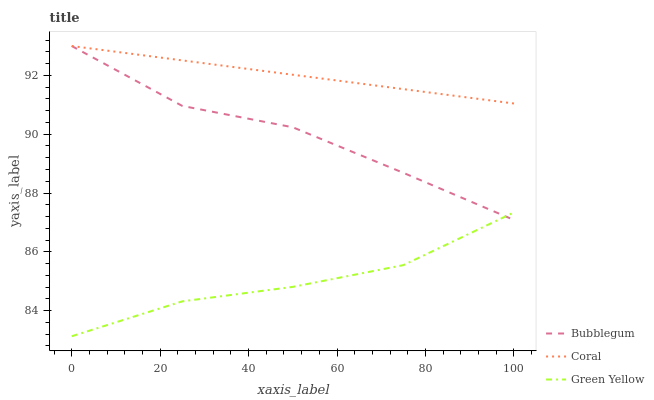Does Green Yellow have the minimum area under the curve?
Answer yes or no. Yes. Does Coral have the maximum area under the curve?
Answer yes or no. Yes. Does Bubblegum have the minimum area under the curve?
Answer yes or no. No. Does Bubblegum have the maximum area under the curve?
Answer yes or no. No. Is Coral the smoothest?
Answer yes or no. Yes. Is Bubblegum the roughest?
Answer yes or no. Yes. Is Green Yellow the smoothest?
Answer yes or no. No. Is Green Yellow the roughest?
Answer yes or no. No. Does Green Yellow have the lowest value?
Answer yes or no. Yes. Does Bubblegum have the lowest value?
Answer yes or no. No. Does Bubblegum have the highest value?
Answer yes or no. Yes. Does Green Yellow have the highest value?
Answer yes or no. No. Is Green Yellow less than Coral?
Answer yes or no. Yes. Is Coral greater than Green Yellow?
Answer yes or no. Yes. Does Coral intersect Bubblegum?
Answer yes or no. Yes. Is Coral less than Bubblegum?
Answer yes or no. No. Is Coral greater than Bubblegum?
Answer yes or no. No. Does Green Yellow intersect Coral?
Answer yes or no. No. 